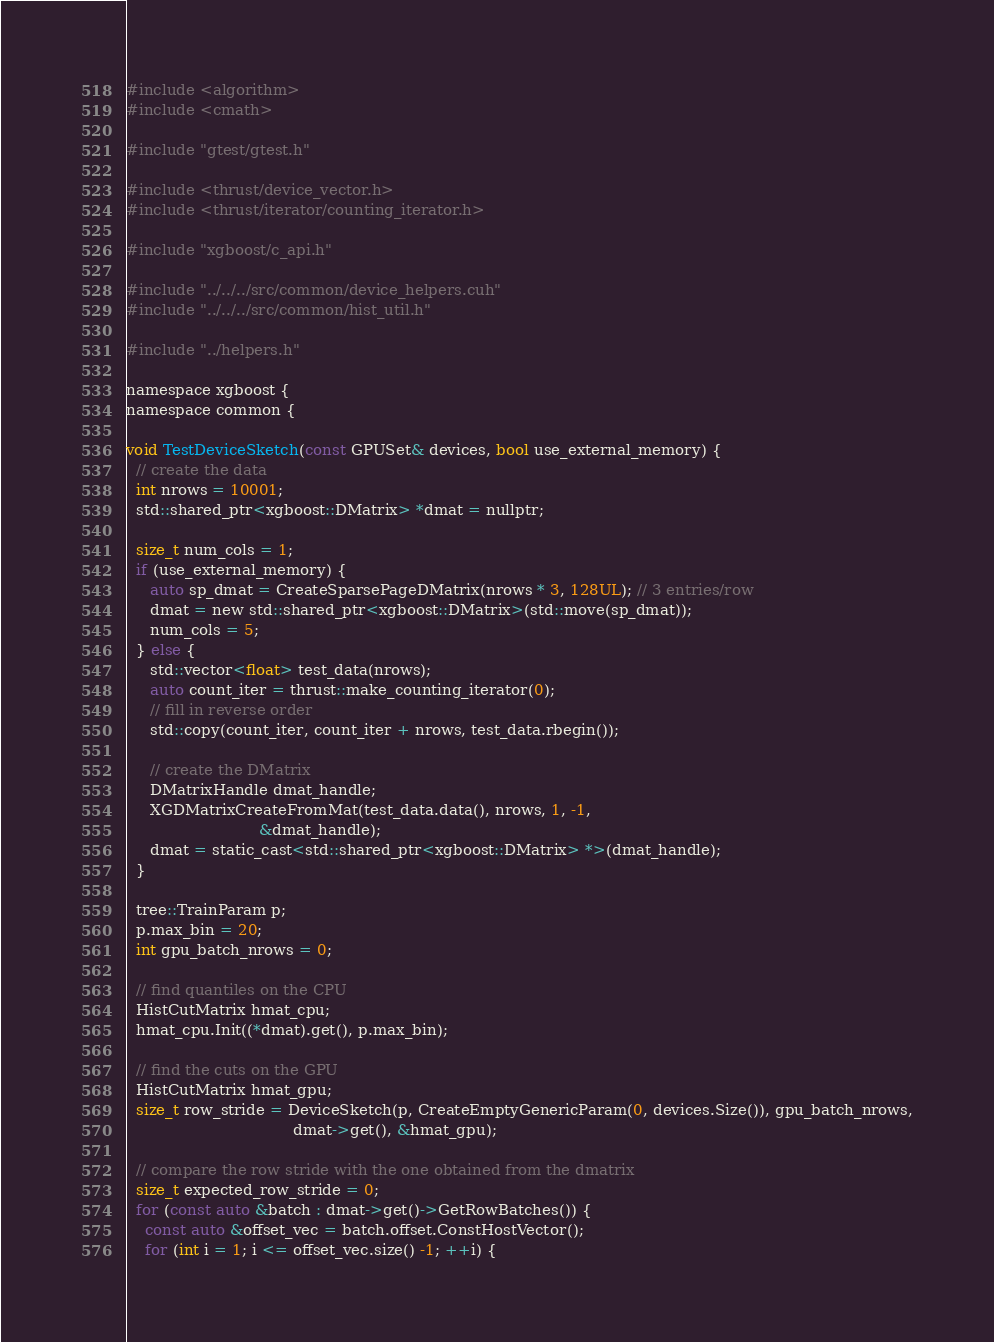<code> <loc_0><loc_0><loc_500><loc_500><_Cuda_>#include <algorithm>
#include <cmath>

#include "gtest/gtest.h"

#include <thrust/device_vector.h>
#include <thrust/iterator/counting_iterator.h>

#include "xgboost/c_api.h"

#include "../../../src/common/device_helpers.cuh"
#include "../../../src/common/hist_util.h"

#include "../helpers.h"

namespace xgboost {
namespace common {

void TestDeviceSketch(const GPUSet& devices, bool use_external_memory) {
  // create the data
  int nrows = 10001;
  std::shared_ptr<xgboost::DMatrix> *dmat = nullptr;

  size_t num_cols = 1;
  if (use_external_memory) {
     auto sp_dmat = CreateSparsePageDMatrix(nrows * 3, 128UL); // 3 entries/row
     dmat = new std::shared_ptr<xgboost::DMatrix>(std::move(sp_dmat));
     num_cols = 5;
  } else {
     std::vector<float> test_data(nrows);
     auto count_iter = thrust::make_counting_iterator(0);
     // fill in reverse order
     std::copy(count_iter, count_iter + nrows, test_data.rbegin());

     // create the DMatrix
     DMatrixHandle dmat_handle;
     XGDMatrixCreateFromMat(test_data.data(), nrows, 1, -1,
                            &dmat_handle);
     dmat = static_cast<std::shared_ptr<xgboost::DMatrix> *>(dmat_handle);
  }

  tree::TrainParam p;
  p.max_bin = 20;
  int gpu_batch_nrows = 0;

  // find quantiles on the CPU
  HistCutMatrix hmat_cpu;
  hmat_cpu.Init((*dmat).get(), p.max_bin);

  // find the cuts on the GPU
  HistCutMatrix hmat_gpu;
  size_t row_stride = DeviceSketch(p, CreateEmptyGenericParam(0, devices.Size()), gpu_batch_nrows,
                                   dmat->get(), &hmat_gpu);

  // compare the row stride with the one obtained from the dmatrix
  size_t expected_row_stride = 0;
  for (const auto &batch : dmat->get()->GetRowBatches()) {
    const auto &offset_vec = batch.offset.ConstHostVector();
    for (int i = 1; i <= offset_vec.size() -1; ++i) {</code> 